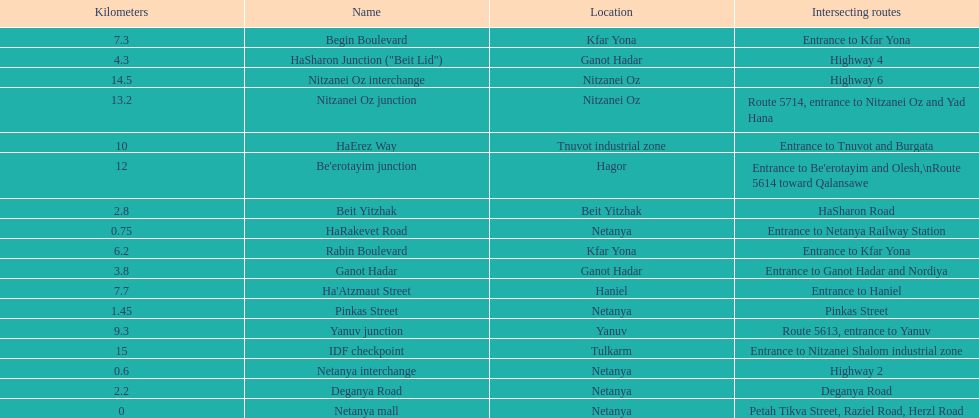After you complete deganya road, what portion comes next? Beit Yitzhak. 